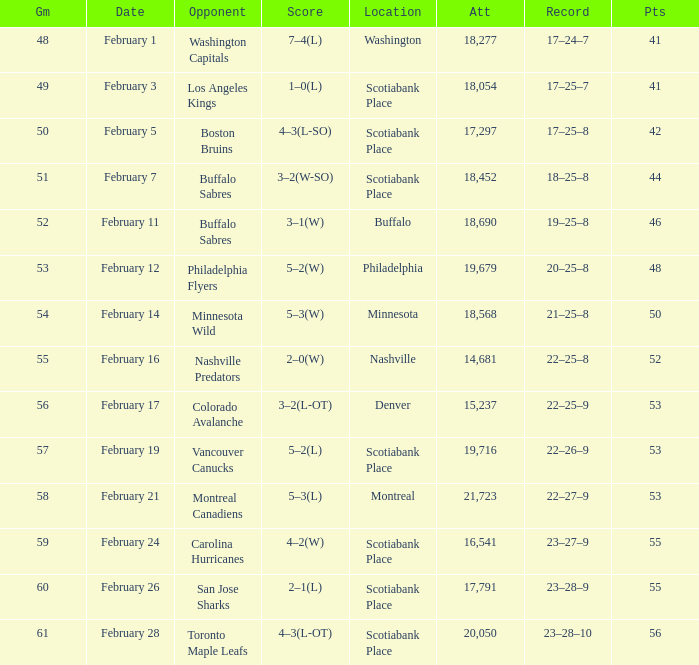What sum of game has an attendance of 18,690? 52.0. 